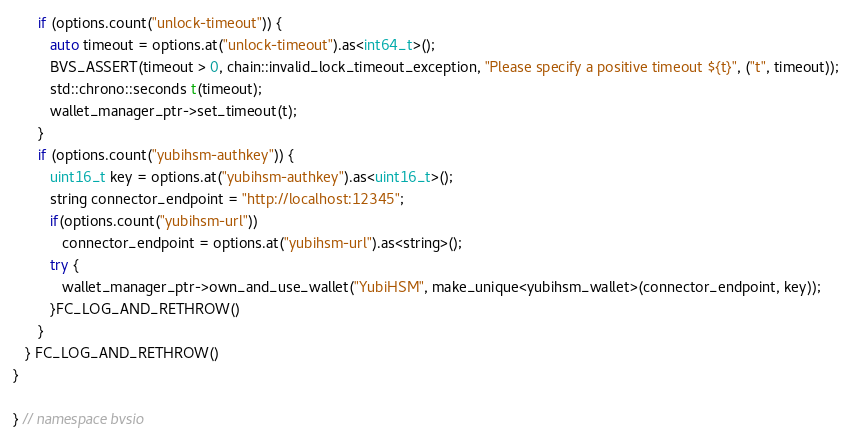<code> <loc_0><loc_0><loc_500><loc_500><_C++_>      if (options.count("unlock-timeout")) {
         auto timeout = options.at("unlock-timeout").as<int64_t>();
         BVS_ASSERT(timeout > 0, chain::invalid_lock_timeout_exception, "Please specify a positive timeout ${t}", ("t", timeout));
         std::chrono::seconds t(timeout);
         wallet_manager_ptr->set_timeout(t);
      }
      if (options.count("yubihsm-authkey")) {
         uint16_t key = options.at("yubihsm-authkey").as<uint16_t>();
         string connector_endpoint = "http://localhost:12345";
         if(options.count("yubihsm-url"))
            connector_endpoint = options.at("yubihsm-url").as<string>();
         try {
            wallet_manager_ptr->own_and_use_wallet("YubiHSM", make_unique<yubihsm_wallet>(connector_endpoint, key));
         }FC_LOG_AND_RETHROW()
      }
   } FC_LOG_AND_RETHROW()
}

} // namespace bvsio
</code> 